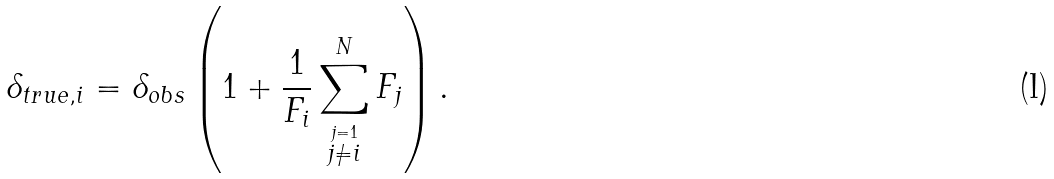<formula> <loc_0><loc_0><loc_500><loc_500>\delta _ { t r u e , i } = \delta _ { o b s } \left ( 1 + \frac { 1 } { F _ { i } } \sum _ { \stackrel { j = 1 } { j \neq i } } ^ { N } F _ { j } \right ) .</formula> 